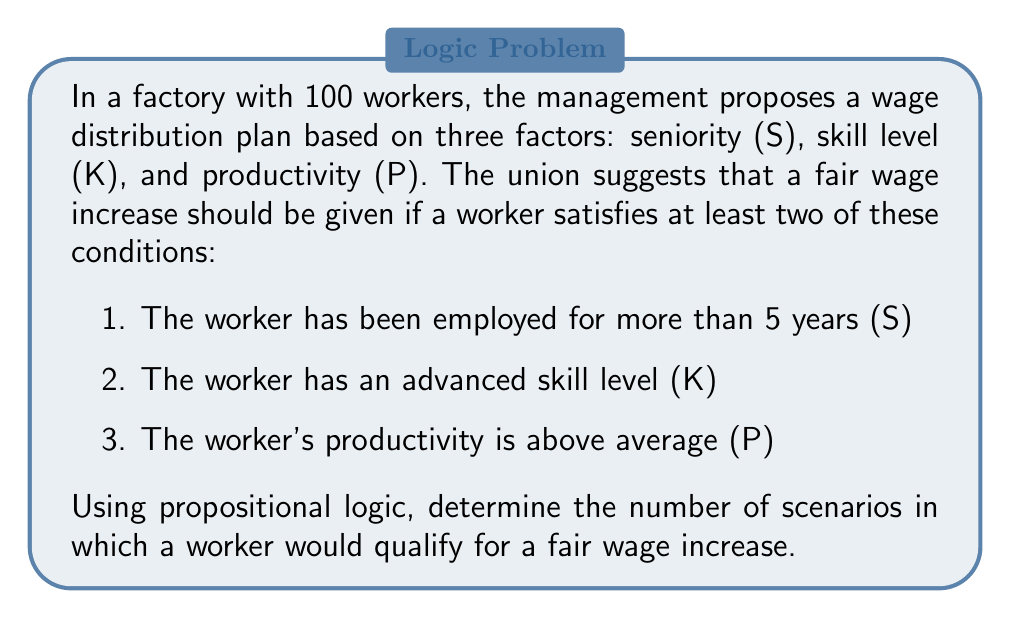Show me your answer to this math problem. To solve this problem, we need to use propositional logic to analyze the different combinations of conditions that would result in a fair wage increase. Let's break it down step-by-step:

1. We have three propositions:
   S: The worker has been employed for more than 5 years
   K: The worker has an advanced skill level
   P: The worker's productivity is above average

2. The condition for a fair wage increase can be expressed in propositional logic as:
   $$(S \land K) \lor (S \land P) \lor (K \land P)$$

3. To determine the number of scenarios, we need to consider all possible combinations of these propositions. There are 8 possible combinations in total:

   $$\begin{array}{ccc|c}
   S & K & P & \text{Qualifies} \\
   \hline
   T & T & T & \text{Yes} \\
   T & T & F & \text{Yes} \\
   T & F & T & \text{Yes} \\
   T & F & F & \text{No} \\
   F & T & T & \text{Yes} \\
   F & T & F & \text{No} \\
   F & F & T & \text{No} \\
   F & F & F & \text{No}
   \end{array}$$

4. Counting the number of "Yes" outcomes, we can see that there are 4 scenarios in which a worker would qualify for a fair wage increase.

This approach ensures that the wage distribution is fair according to the union's suggestion, as it considers multiple factors and doesn't rely on a single criterion.
Answer: There are 4 scenarios in which a worker would qualify for a fair wage increase according to the given conditions. 